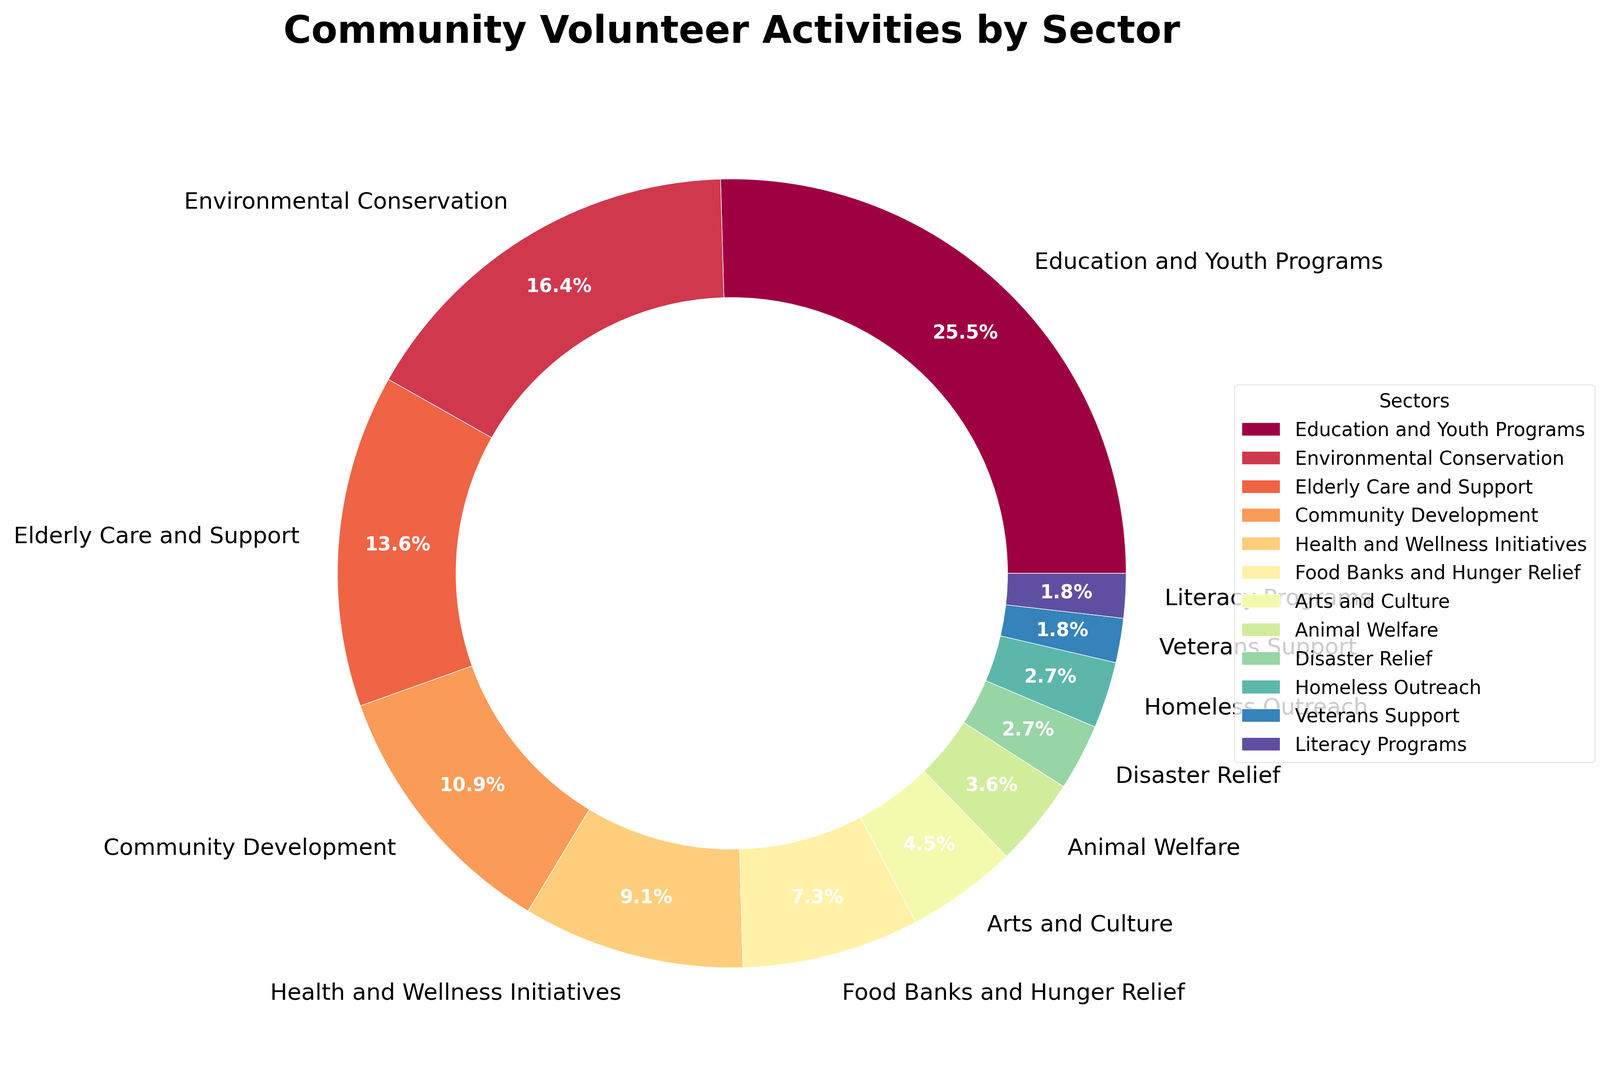What's the largest sector in terms of volunteer activities? The largest sector can be identified by looking at the percentage values given in the pie chart. The sector with the highest percentage is Education and Youth Programs with 28%.
Answer: Education and Youth Programs Which sector has the smallest proportion of volunteer activities, and what is its percentage? The smallest sector can be identified by looking at the percentage values given in the pie chart. The smallest sectors are Veterans Support and Literacy Programs, each with 2%.
Answer: Veterans Support and Literacy Programs, 2% How much more volunteer activity percentage does Education and Youth Programs have compared to Environmental Conservation? First, identify the percentages for Education and Youth Programs (28%) and Environmental Conservation (18%). Then, calculate the difference: 28% - 18% = 10%.
Answer: 10% What is the combined percentage of volunteer activities in Environmental Conservation and Elderly Care and Support? Add the percentages of Environmental Conservation (18%) and Elderly Care and Support (15%). The combined total is 18% + 15% = 33%.
Answer: 33% Rank the top three sectors by their volunteer activity percentage. Identify the percentages and rank them in descending order. The top three are:
1) Education and Youth Programs (28%)
2) Environmental Conservation (18%)
3) Elderly Care and Support (15%)
Answer: Education and Youth Programs, Environmental Conservation, Elderly Care and Support What percentage of volunteer activities is dedicated to non-social sectors (Environmental Conservation, Arts and Culture, Animal Welfare, and Disaster Relief)? Add the percentages of Environmental Conservation (18%), Arts and Culture (5%), Animal Welfare (4%), and Disaster Relief (3%).
The total is 18% + 5% + 4% + 3% = 30%.
Answer: 30% Are there more volunteer activities in Health and Wellness Initiatives or Food Banks and Hunger Relief? By how much? Compare the percentages of Health and Wellness Initiatives (10%) and Food Banks and Hunger Relief (8%). Health and Wellness Initiatives have 2% more.
Answer: Health and Wellness Initiatives by 2% What is the average percentage of volunteer activities across the bottom four sectors (Disaster Relief, Homeless Outreach, Veterans Support, and Literacy Programs)? Add the percentages of the four sectors:
Disaster Relief (3%), Homeless Outreach (3%), Veterans Support (2%), Literacy Programs (2%).
The total is 3% + 3% + 2% + 2% = 10%. The average is 10% / 4 = 2.5%.
Answer: 2.5% If sectors with less than 5% are combined into a single category, what percentage of volunteer activities would that new category represent? Identify and sum the percentages of sectors less than 5%: 
Arts and Culture (5%), Animal Welfare (4%), Disaster Relief (3%), Homeless Outreach (3%), Veterans Support (2%), Literacy Programs (2%). 
Summing them up: 4% + 3% + 3% + 2% + 2% = 14%.
Answer: 14% 